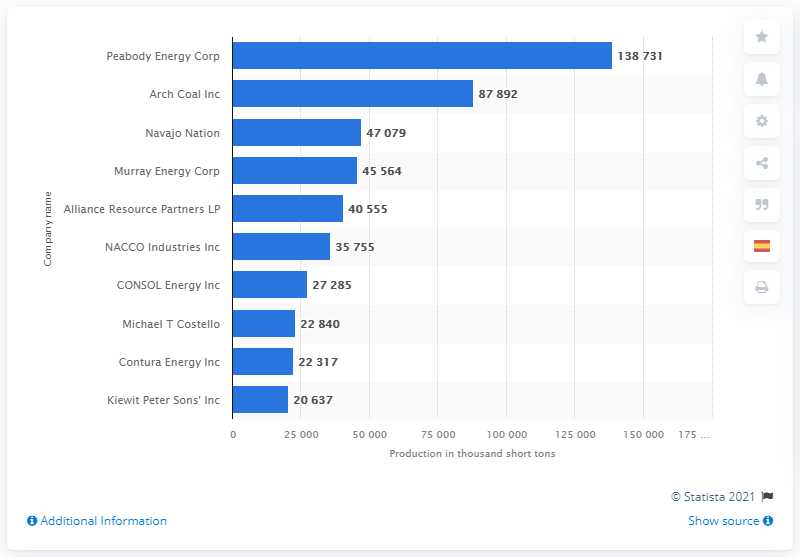List a handful of essential elements in this visual. In 2019, Arch Coal Inc. was the second largest coal producer in the United States. 